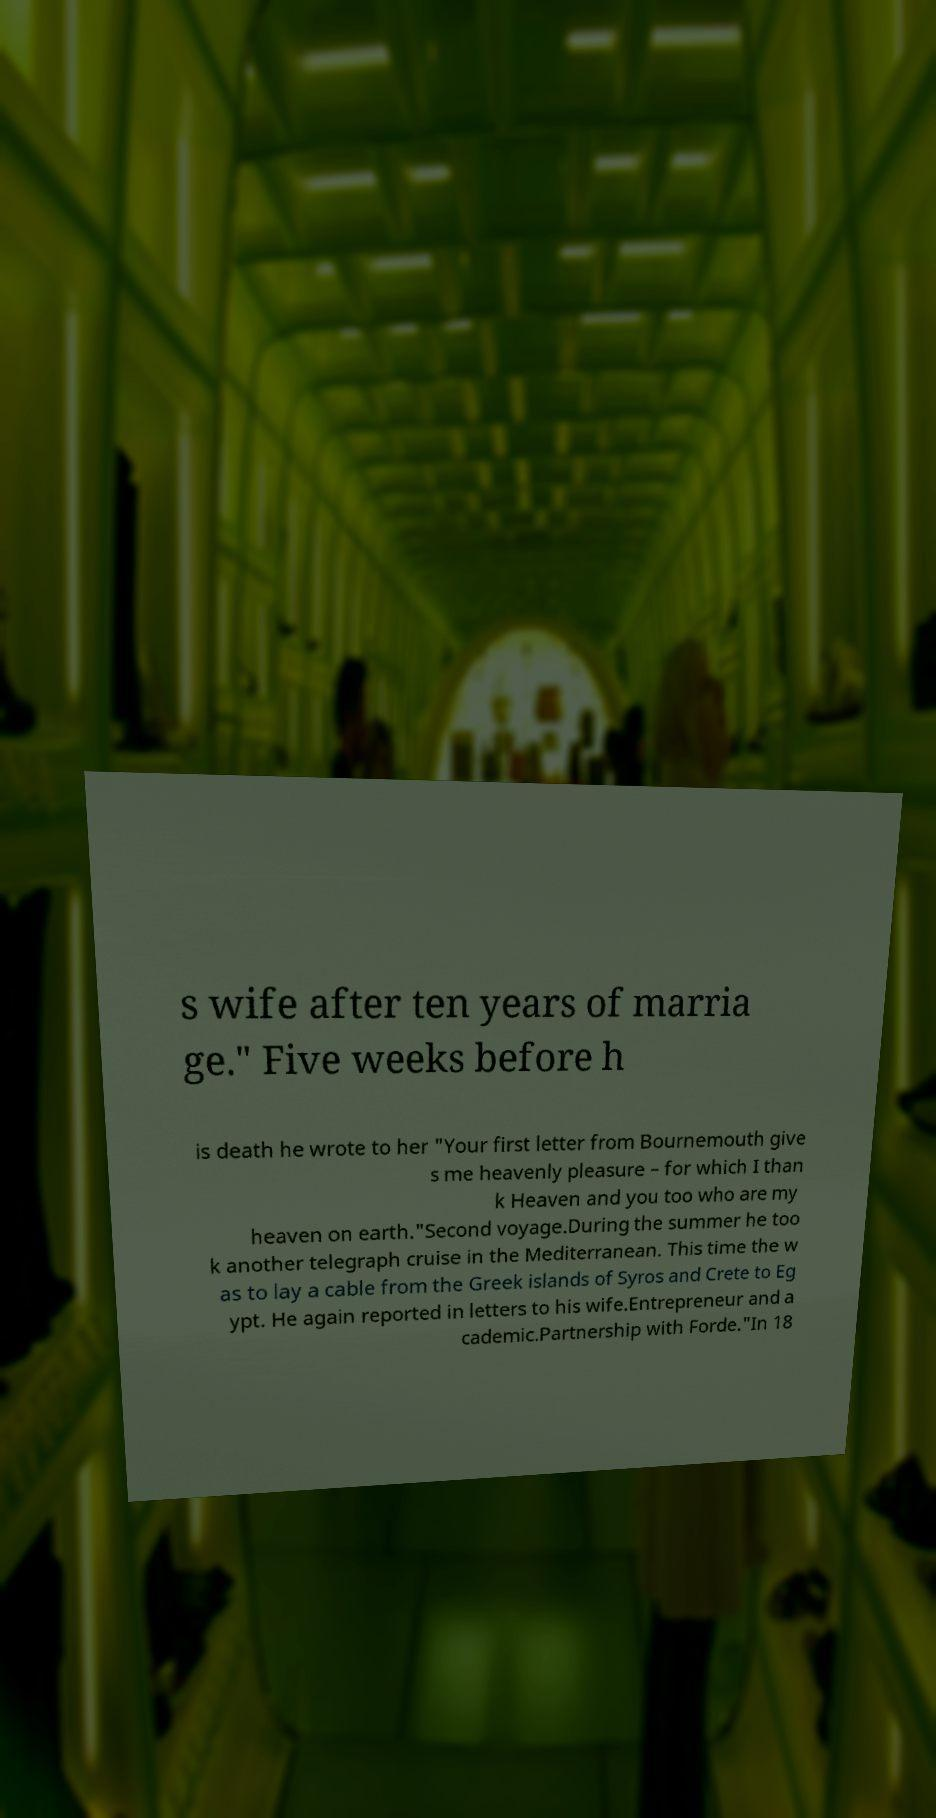Please read and relay the text visible in this image. What does it say? s wife after ten years of marria ge." Five weeks before h is death he wrote to her "Your first letter from Bournemouth give s me heavenly pleasure – for which I than k Heaven and you too who are my heaven on earth."Second voyage.During the summer he too k another telegraph cruise in the Mediterranean. This time the w as to lay a cable from the Greek islands of Syros and Crete to Eg ypt. He again reported in letters to his wife.Entrepreneur and a cademic.Partnership with Forde."In 18 